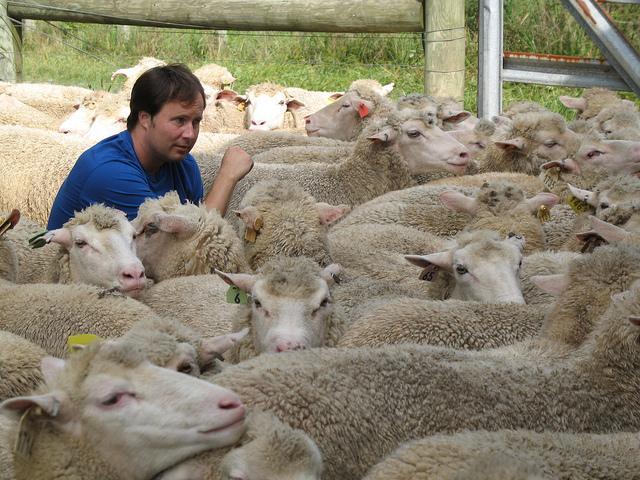How many bows are on the cake but not the shoes?
Give a very brief answer. 0. 